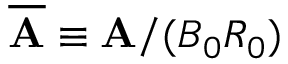<formula> <loc_0><loc_0><loc_500><loc_500>\overline { A } \equiv A / ( B _ { 0 } R _ { 0 } )</formula> 